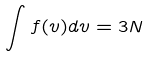<formula> <loc_0><loc_0><loc_500><loc_500>\int f ( v ) d v = 3 N</formula> 